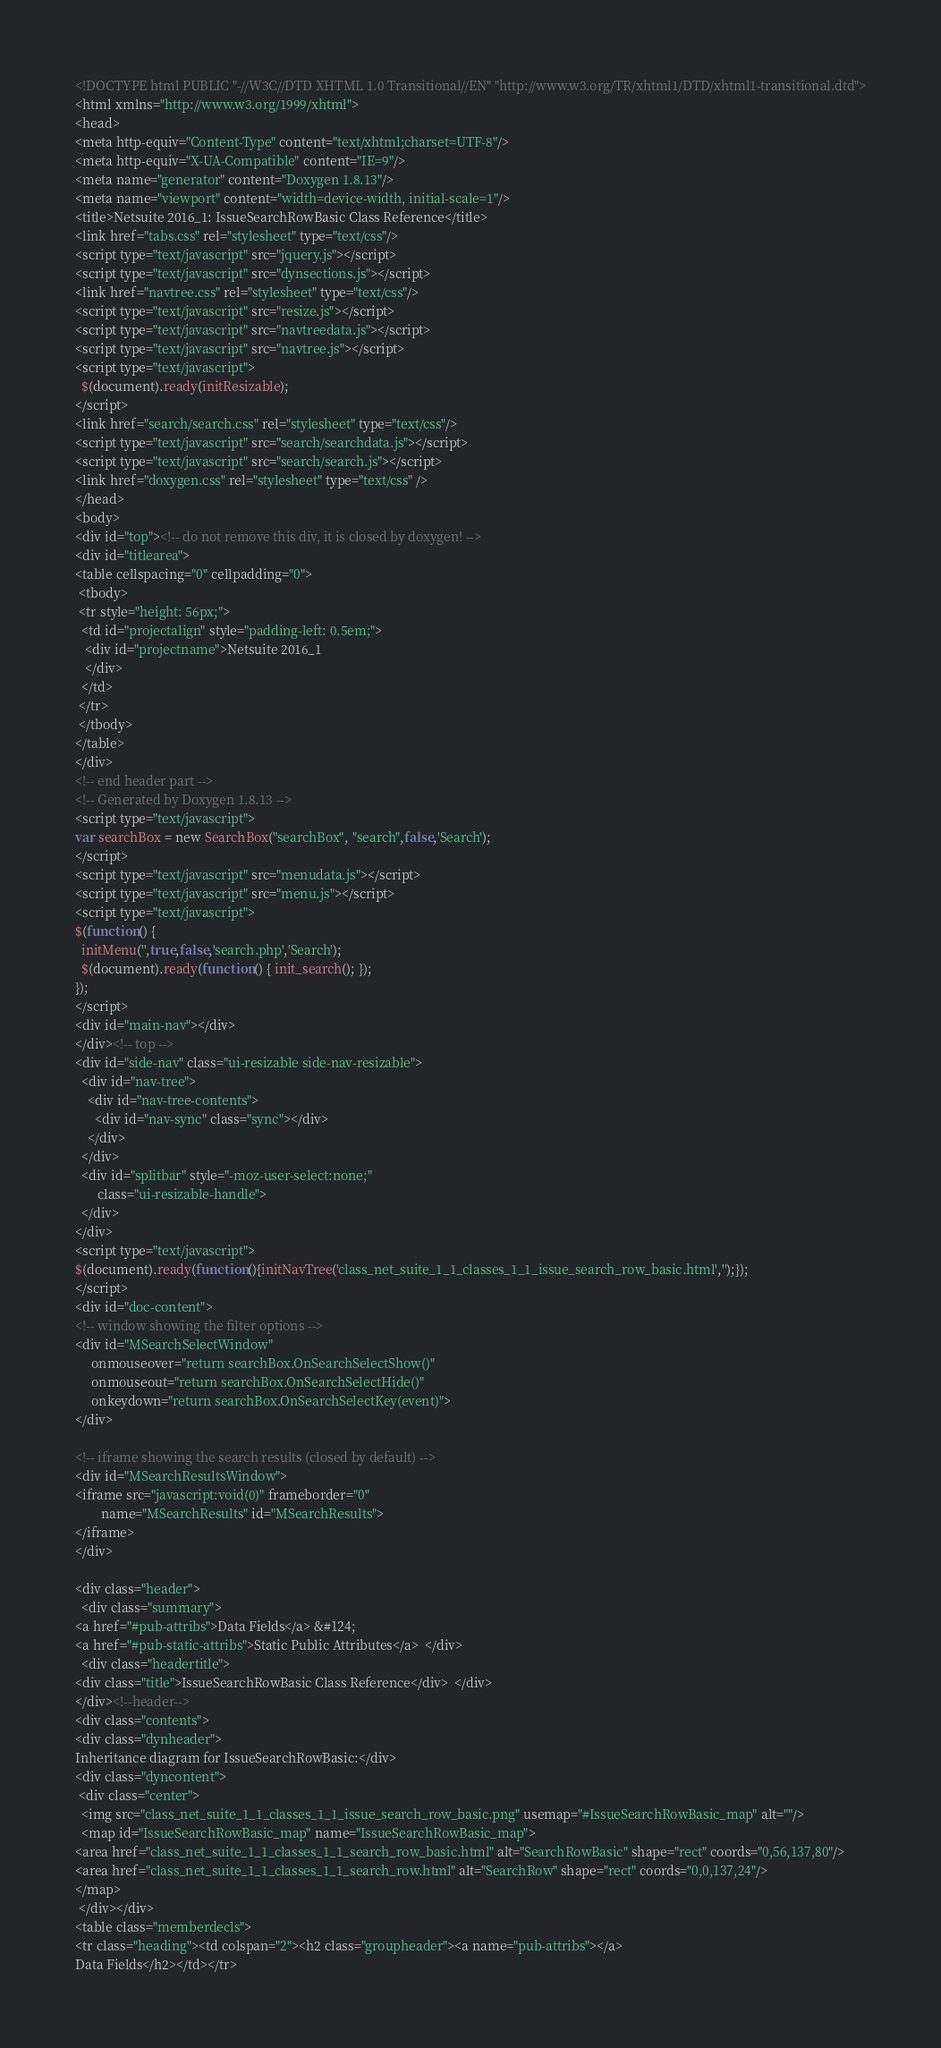Convert code to text. <code><loc_0><loc_0><loc_500><loc_500><_HTML_><!DOCTYPE html PUBLIC "-//W3C//DTD XHTML 1.0 Transitional//EN" "http://www.w3.org/TR/xhtml1/DTD/xhtml1-transitional.dtd">
<html xmlns="http://www.w3.org/1999/xhtml">
<head>
<meta http-equiv="Content-Type" content="text/xhtml;charset=UTF-8"/>
<meta http-equiv="X-UA-Compatible" content="IE=9"/>
<meta name="generator" content="Doxygen 1.8.13"/>
<meta name="viewport" content="width=device-width, initial-scale=1"/>
<title>Netsuite 2016_1: IssueSearchRowBasic Class Reference</title>
<link href="tabs.css" rel="stylesheet" type="text/css"/>
<script type="text/javascript" src="jquery.js"></script>
<script type="text/javascript" src="dynsections.js"></script>
<link href="navtree.css" rel="stylesheet" type="text/css"/>
<script type="text/javascript" src="resize.js"></script>
<script type="text/javascript" src="navtreedata.js"></script>
<script type="text/javascript" src="navtree.js"></script>
<script type="text/javascript">
  $(document).ready(initResizable);
</script>
<link href="search/search.css" rel="stylesheet" type="text/css"/>
<script type="text/javascript" src="search/searchdata.js"></script>
<script type="text/javascript" src="search/search.js"></script>
<link href="doxygen.css" rel="stylesheet" type="text/css" />
</head>
<body>
<div id="top"><!-- do not remove this div, it is closed by doxygen! -->
<div id="titlearea">
<table cellspacing="0" cellpadding="0">
 <tbody>
 <tr style="height: 56px;">
  <td id="projectalign" style="padding-left: 0.5em;">
   <div id="projectname">Netsuite 2016_1
   </div>
  </td>
 </tr>
 </tbody>
</table>
</div>
<!-- end header part -->
<!-- Generated by Doxygen 1.8.13 -->
<script type="text/javascript">
var searchBox = new SearchBox("searchBox", "search",false,'Search');
</script>
<script type="text/javascript" src="menudata.js"></script>
<script type="text/javascript" src="menu.js"></script>
<script type="text/javascript">
$(function() {
  initMenu('',true,false,'search.php','Search');
  $(document).ready(function() { init_search(); });
});
</script>
<div id="main-nav"></div>
</div><!-- top -->
<div id="side-nav" class="ui-resizable side-nav-resizable">
  <div id="nav-tree">
    <div id="nav-tree-contents">
      <div id="nav-sync" class="sync"></div>
    </div>
  </div>
  <div id="splitbar" style="-moz-user-select:none;" 
       class="ui-resizable-handle">
  </div>
</div>
<script type="text/javascript">
$(document).ready(function(){initNavTree('class_net_suite_1_1_classes_1_1_issue_search_row_basic.html','');});
</script>
<div id="doc-content">
<!-- window showing the filter options -->
<div id="MSearchSelectWindow"
     onmouseover="return searchBox.OnSearchSelectShow()"
     onmouseout="return searchBox.OnSearchSelectHide()"
     onkeydown="return searchBox.OnSearchSelectKey(event)">
</div>

<!-- iframe showing the search results (closed by default) -->
<div id="MSearchResultsWindow">
<iframe src="javascript:void(0)" frameborder="0" 
        name="MSearchResults" id="MSearchResults">
</iframe>
</div>

<div class="header">
  <div class="summary">
<a href="#pub-attribs">Data Fields</a> &#124;
<a href="#pub-static-attribs">Static Public Attributes</a>  </div>
  <div class="headertitle">
<div class="title">IssueSearchRowBasic Class Reference</div>  </div>
</div><!--header-->
<div class="contents">
<div class="dynheader">
Inheritance diagram for IssueSearchRowBasic:</div>
<div class="dyncontent">
 <div class="center">
  <img src="class_net_suite_1_1_classes_1_1_issue_search_row_basic.png" usemap="#IssueSearchRowBasic_map" alt=""/>
  <map id="IssueSearchRowBasic_map" name="IssueSearchRowBasic_map">
<area href="class_net_suite_1_1_classes_1_1_search_row_basic.html" alt="SearchRowBasic" shape="rect" coords="0,56,137,80"/>
<area href="class_net_suite_1_1_classes_1_1_search_row.html" alt="SearchRow" shape="rect" coords="0,0,137,24"/>
</map>
 </div></div>
<table class="memberdecls">
<tr class="heading"><td colspan="2"><h2 class="groupheader"><a name="pub-attribs"></a>
Data Fields</h2></td></tr></code> 